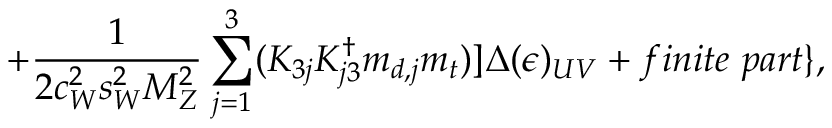Convert formula to latex. <formula><loc_0><loc_0><loc_500><loc_500>+ { \frac { 1 } { 2 c _ { W } ^ { 2 } s _ { W } ^ { 2 } M _ { Z } ^ { 2 } } } \sum _ { j = 1 } ^ { 3 } ( K _ { 3 j } K _ { j 3 } ^ { \dag } m _ { d , j } m _ { t } ) ] \Delta ( \epsilon ) _ { U V } + f i n i t e \ p a r t \} ,</formula> 